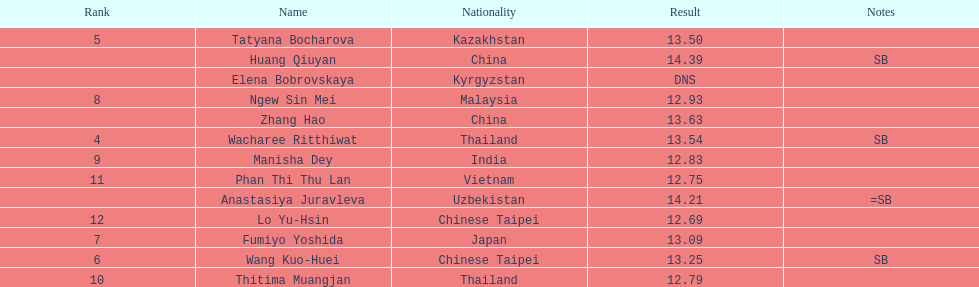How many athletes had a better result than tatyana bocharova? 4. Give me the full table as a dictionary. {'header': ['Rank', 'Name', 'Nationality', 'Result', 'Notes'], 'rows': [['5', 'Tatyana Bocharova', 'Kazakhstan', '13.50', ''], ['', 'Huang Qiuyan', 'China', '14.39', 'SB'], ['', 'Elena Bobrovskaya', 'Kyrgyzstan', 'DNS', ''], ['8', 'Ngew Sin Mei', 'Malaysia', '12.93', ''], ['', 'Zhang Hao', 'China', '13.63', ''], ['4', 'Wacharee Ritthiwat', 'Thailand', '13.54', 'SB'], ['9', 'Manisha Dey', 'India', '12.83', ''], ['11', 'Phan Thi Thu Lan', 'Vietnam', '12.75', ''], ['', 'Anastasiya Juravleva', 'Uzbekistan', '14.21', '=SB'], ['12', 'Lo Yu-Hsin', 'Chinese Taipei', '12.69', ''], ['7', 'Fumiyo Yoshida', 'Japan', '13.09', ''], ['6', 'Wang Kuo-Huei', 'Chinese Taipei', '13.25', 'SB'], ['10', 'Thitima Muangjan', 'Thailand', '12.79', '']]} 